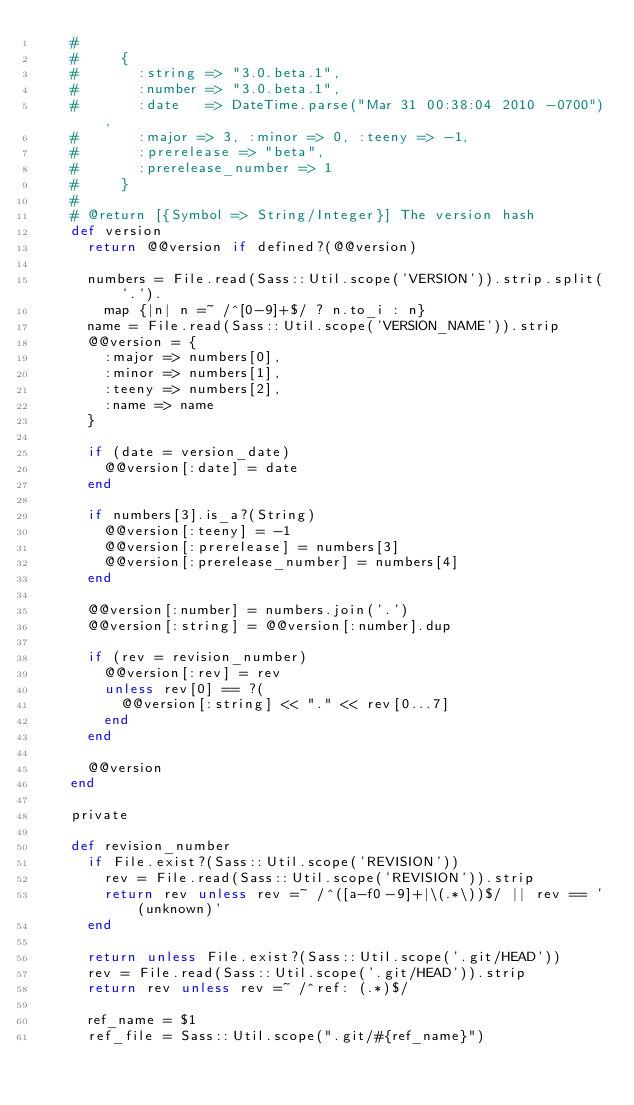Convert code to text. <code><loc_0><loc_0><loc_500><loc_500><_Ruby_>    #
    #     {
    #       :string => "3.0.beta.1",
    #       :number => "3.0.beta.1",
    #       :date   => DateTime.parse("Mar 31 00:38:04 2010 -0700"),
    #       :major => 3, :minor => 0, :teeny => -1,
    #       :prerelease => "beta",
    #       :prerelease_number => 1
    #     }
    #
    # @return [{Symbol => String/Integer}] The version hash
    def version
      return @@version if defined?(@@version)

      numbers = File.read(Sass::Util.scope('VERSION')).strip.split('.').
        map {|n| n =~ /^[0-9]+$/ ? n.to_i : n}
      name = File.read(Sass::Util.scope('VERSION_NAME')).strip
      @@version = {
        :major => numbers[0],
        :minor => numbers[1],
        :teeny => numbers[2],
        :name => name
      }

      if (date = version_date)
        @@version[:date] = date
      end

      if numbers[3].is_a?(String)
        @@version[:teeny] = -1
        @@version[:prerelease] = numbers[3]
        @@version[:prerelease_number] = numbers[4]
      end

      @@version[:number] = numbers.join('.')
      @@version[:string] = @@version[:number].dup

      if (rev = revision_number)
        @@version[:rev] = rev
        unless rev[0] == ?(
          @@version[:string] << "." << rev[0...7]
        end
      end

      @@version
    end

    private

    def revision_number
      if File.exist?(Sass::Util.scope('REVISION'))
        rev = File.read(Sass::Util.scope('REVISION')).strip
        return rev unless rev =~ /^([a-f0-9]+|\(.*\))$/ || rev == '(unknown)'
      end

      return unless File.exist?(Sass::Util.scope('.git/HEAD'))
      rev = File.read(Sass::Util.scope('.git/HEAD')).strip
      return rev unless rev =~ /^ref: (.*)$/

      ref_name = $1
      ref_file = Sass::Util.scope(".git/#{ref_name}")</code> 